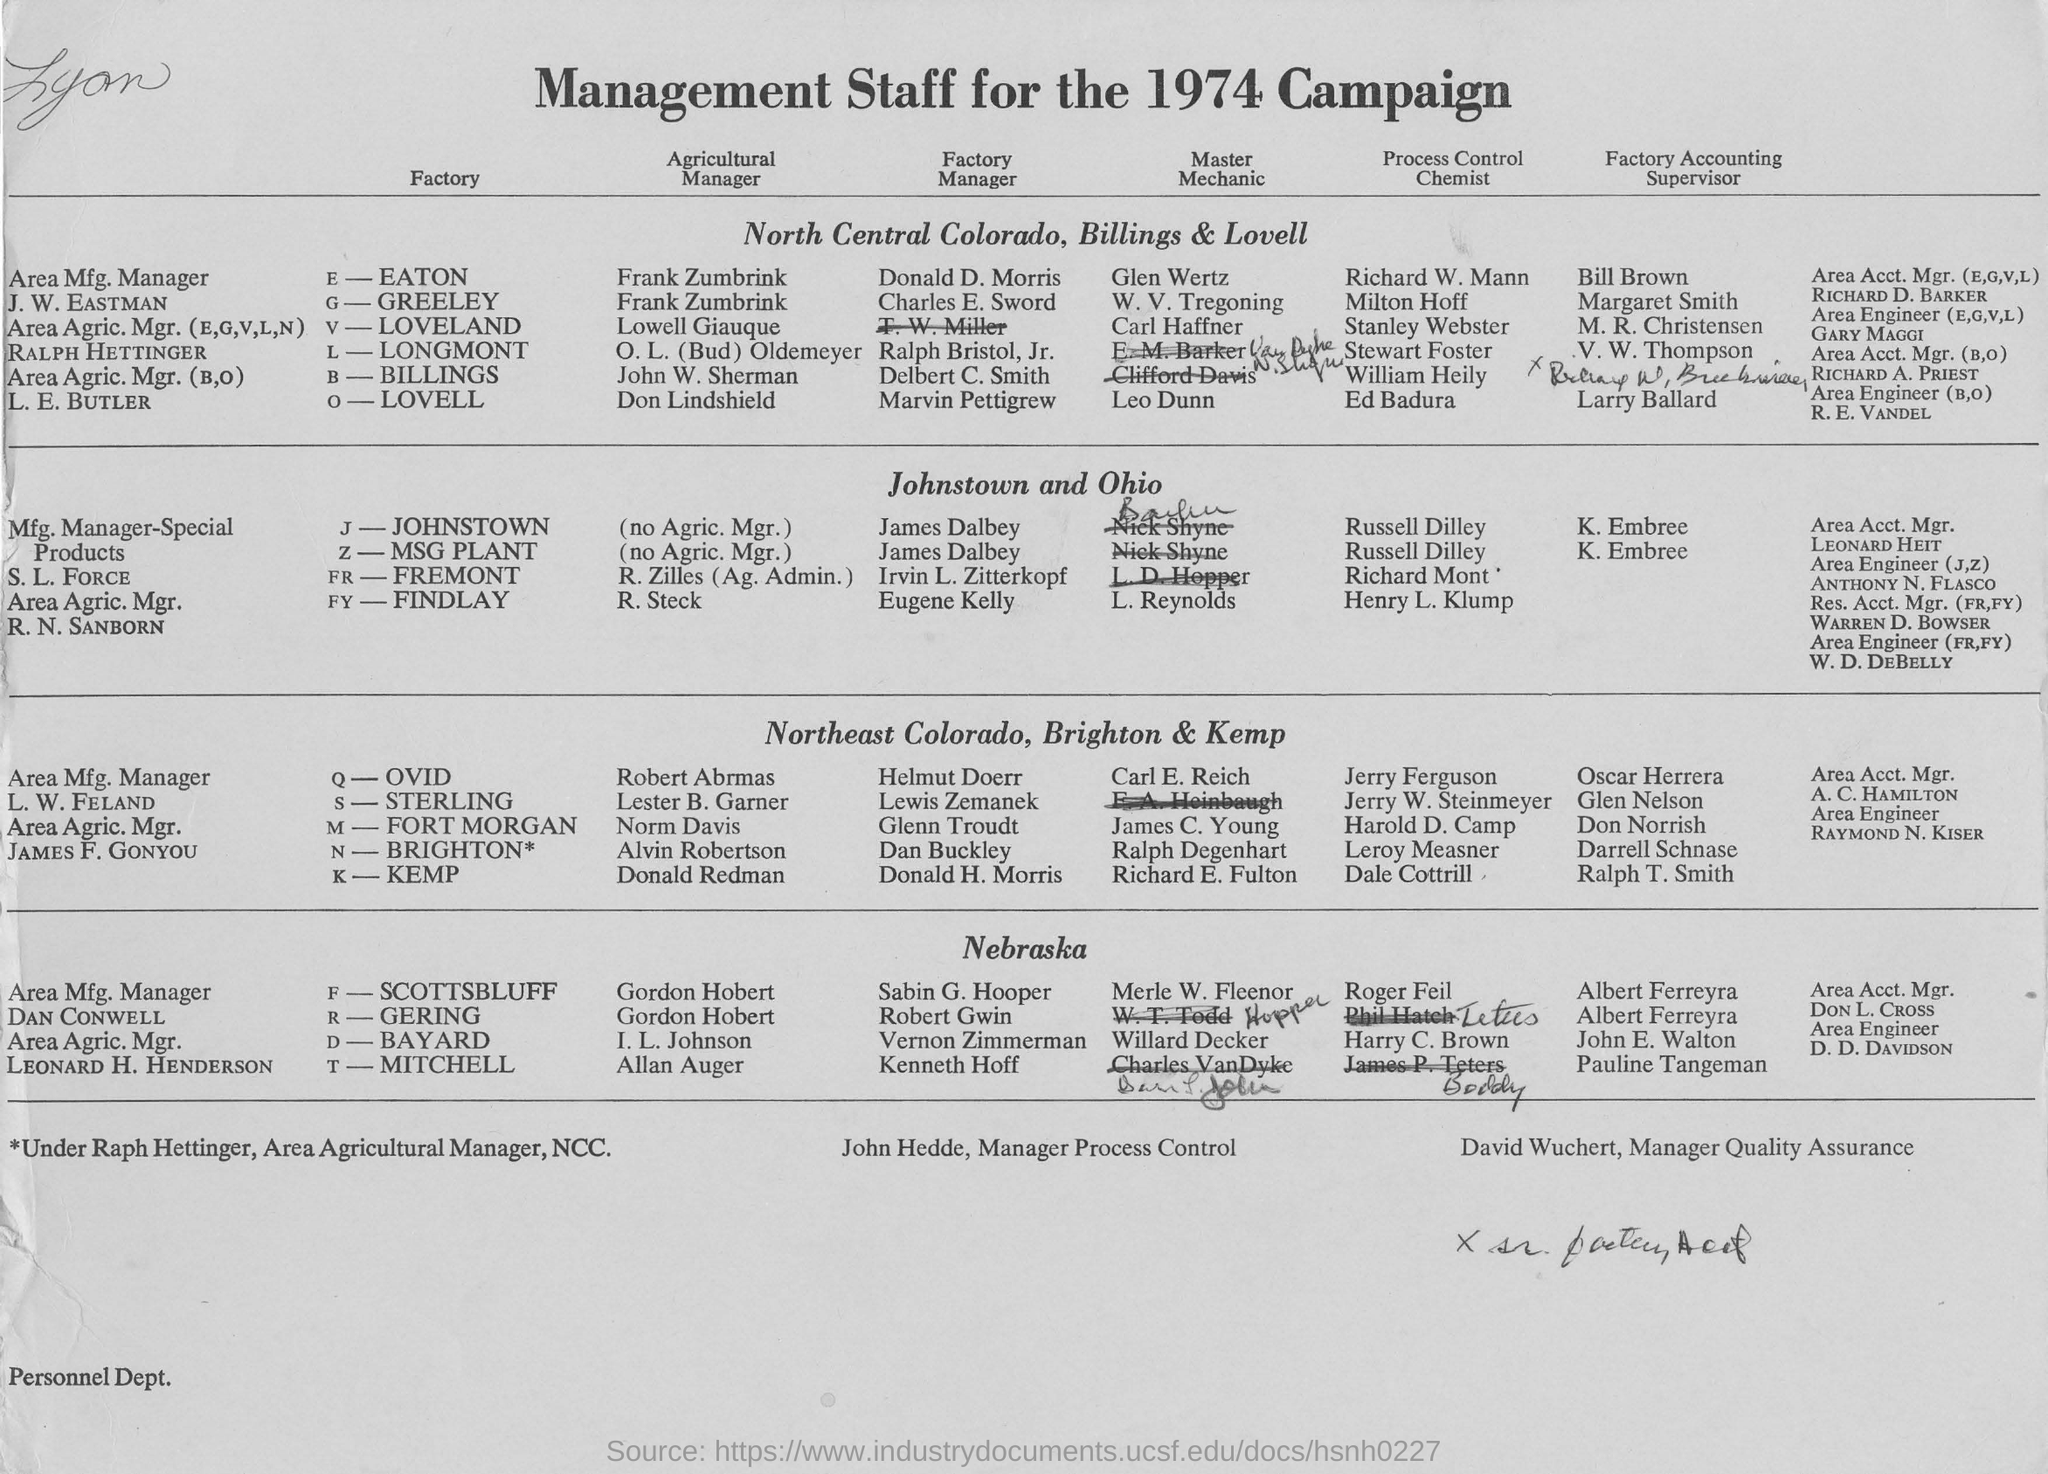Point out several critical features in this image. The person in charge of quality assurance is David Wuchert. The manager of process control is John Hedde. The title of the document is 'Management Staff for the 1974 Campaign'. 